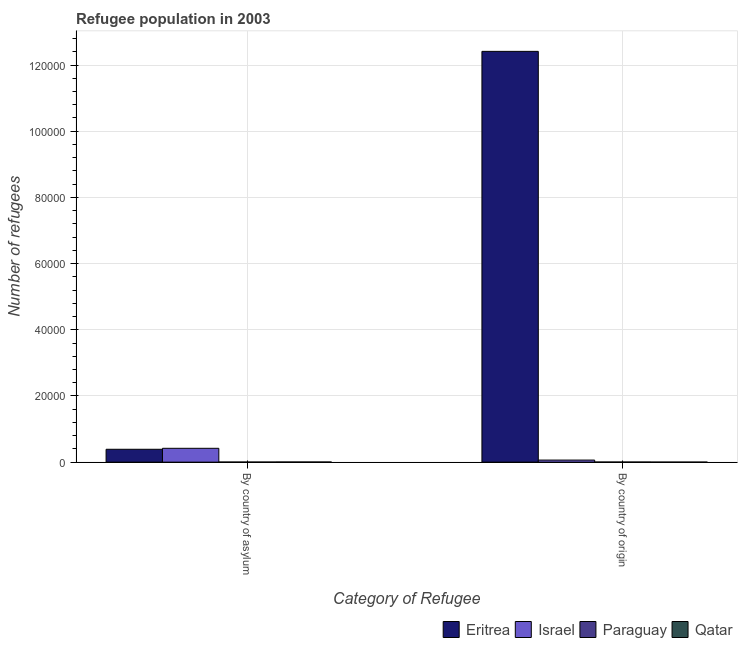How many different coloured bars are there?
Your answer should be very brief. 4. How many groups of bars are there?
Ensure brevity in your answer.  2. Are the number of bars on each tick of the X-axis equal?
Your response must be concise. Yes. How many bars are there on the 1st tick from the right?
Provide a succinct answer. 4. What is the label of the 2nd group of bars from the left?
Your response must be concise. By country of origin. What is the number of refugees by country of asylum in Paraguay?
Your answer should be very brief. 28. Across all countries, what is the maximum number of refugees by country of asylum?
Offer a terse response. 4179. Across all countries, what is the minimum number of refugees by country of origin?
Offer a very short reply. 13. In which country was the number of refugees by country of origin maximum?
Your response must be concise. Eritrea. In which country was the number of refugees by country of asylum minimum?
Offer a very short reply. Paraguay. What is the total number of refugees by country of asylum in the graph?
Provide a short and direct response. 8142. What is the difference between the number of refugees by country of origin in Paraguay and that in Eritrea?
Keep it short and to the point. -1.24e+05. What is the difference between the number of refugees by country of asylum in Paraguay and the number of refugees by country of origin in Qatar?
Keep it short and to the point. 15. What is the average number of refugees by country of asylum per country?
Make the answer very short. 2035.5. What is the difference between the number of refugees by country of origin and number of refugees by country of asylum in Eritrea?
Your response must be concise. 1.20e+05. In how many countries, is the number of refugees by country of origin greater than 52000 ?
Offer a terse response. 1. What is the ratio of the number of refugees by country of asylum in Eritrea to that in Israel?
Offer a terse response. 0.93. Is the number of refugees by country of asylum in Israel less than that in Eritrea?
Make the answer very short. No. In how many countries, is the number of refugees by country of asylum greater than the average number of refugees by country of asylum taken over all countries?
Make the answer very short. 2. What does the 4th bar from the left in By country of asylum represents?
Offer a very short reply. Qatar. What does the 4th bar from the right in By country of origin represents?
Provide a short and direct response. Eritrea. Are all the bars in the graph horizontal?
Ensure brevity in your answer.  No. How many countries are there in the graph?
Your response must be concise. 4. Are the values on the major ticks of Y-axis written in scientific E-notation?
Your response must be concise. No. Does the graph contain any zero values?
Offer a very short reply. No. Where does the legend appear in the graph?
Offer a terse response. Bottom right. How many legend labels are there?
Your response must be concise. 4. What is the title of the graph?
Keep it short and to the point. Refugee population in 2003. What is the label or title of the X-axis?
Your answer should be very brief. Category of Refugee. What is the label or title of the Y-axis?
Provide a succinct answer. Number of refugees. What is the Number of refugees in Eritrea in By country of asylum?
Your answer should be compact. 3889. What is the Number of refugees of Israel in By country of asylum?
Provide a succinct answer. 4179. What is the Number of refugees in Paraguay in By country of asylum?
Give a very brief answer. 28. What is the Number of refugees of Qatar in By country of asylum?
Ensure brevity in your answer.  46. What is the Number of refugees in Eritrea in By country of origin?
Ensure brevity in your answer.  1.24e+05. What is the Number of refugees in Israel in By country of origin?
Offer a terse response. 625. What is the Number of refugees in Paraguay in By country of origin?
Offer a very short reply. 32. Across all Category of Refugee, what is the maximum Number of refugees of Eritrea?
Offer a terse response. 1.24e+05. Across all Category of Refugee, what is the maximum Number of refugees in Israel?
Provide a succinct answer. 4179. Across all Category of Refugee, what is the maximum Number of refugees in Qatar?
Keep it short and to the point. 46. Across all Category of Refugee, what is the minimum Number of refugees in Eritrea?
Offer a very short reply. 3889. Across all Category of Refugee, what is the minimum Number of refugees in Israel?
Provide a short and direct response. 625. What is the total Number of refugees of Eritrea in the graph?
Offer a very short reply. 1.28e+05. What is the total Number of refugees of Israel in the graph?
Your answer should be very brief. 4804. What is the difference between the Number of refugees in Eritrea in By country of asylum and that in By country of origin?
Your response must be concise. -1.20e+05. What is the difference between the Number of refugees of Israel in By country of asylum and that in By country of origin?
Your answer should be very brief. 3554. What is the difference between the Number of refugees of Paraguay in By country of asylum and that in By country of origin?
Make the answer very short. -4. What is the difference between the Number of refugees of Eritrea in By country of asylum and the Number of refugees of Israel in By country of origin?
Provide a succinct answer. 3264. What is the difference between the Number of refugees of Eritrea in By country of asylum and the Number of refugees of Paraguay in By country of origin?
Offer a terse response. 3857. What is the difference between the Number of refugees in Eritrea in By country of asylum and the Number of refugees in Qatar in By country of origin?
Your answer should be very brief. 3876. What is the difference between the Number of refugees in Israel in By country of asylum and the Number of refugees in Paraguay in By country of origin?
Make the answer very short. 4147. What is the difference between the Number of refugees in Israel in By country of asylum and the Number of refugees in Qatar in By country of origin?
Ensure brevity in your answer.  4166. What is the average Number of refugees of Eritrea per Category of Refugee?
Offer a terse response. 6.40e+04. What is the average Number of refugees in Israel per Category of Refugee?
Ensure brevity in your answer.  2402. What is the average Number of refugees in Paraguay per Category of Refugee?
Your response must be concise. 30. What is the average Number of refugees of Qatar per Category of Refugee?
Make the answer very short. 29.5. What is the difference between the Number of refugees in Eritrea and Number of refugees in Israel in By country of asylum?
Your response must be concise. -290. What is the difference between the Number of refugees in Eritrea and Number of refugees in Paraguay in By country of asylum?
Ensure brevity in your answer.  3861. What is the difference between the Number of refugees of Eritrea and Number of refugees of Qatar in By country of asylum?
Make the answer very short. 3843. What is the difference between the Number of refugees of Israel and Number of refugees of Paraguay in By country of asylum?
Keep it short and to the point. 4151. What is the difference between the Number of refugees in Israel and Number of refugees in Qatar in By country of asylum?
Your response must be concise. 4133. What is the difference between the Number of refugees of Paraguay and Number of refugees of Qatar in By country of asylum?
Offer a very short reply. -18. What is the difference between the Number of refugees of Eritrea and Number of refugees of Israel in By country of origin?
Offer a terse response. 1.23e+05. What is the difference between the Number of refugees in Eritrea and Number of refugees in Paraguay in By country of origin?
Ensure brevity in your answer.  1.24e+05. What is the difference between the Number of refugees of Eritrea and Number of refugees of Qatar in By country of origin?
Keep it short and to the point. 1.24e+05. What is the difference between the Number of refugees in Israel and Number of refugees in Paraguay in By country of origin?
Offer a very short reply. 593. What is the difference between the Number of refugees of Israel and Number of refugees of Qatar in By country of origin?
Ensure brevity in your answer.  612. What is the difference between the Number of refugees in Paraguay and Number of refugees in Qatar in By country of origin?
Ensure brevity in your answer.  19. What is the ratio of the Number of refugees of Eritrea in By country of asylum to that in By country of origin?
Offer a terse response. 0.03. What is the ratio of the Number of refugees in Israel in By country of asylum to that in By country of origin?
Keep it short and to the point. 6.69. What is the ratio of the Number of refugees in Qatar in By country of asylum to that in By country of origin?
Your response must be concise. 3.54. What is the difference between the highest and the second highest Number of refugees of Eritrea?
Your response must be concise. 1.20e+05. What is the difference between the highest and the second highest Number of refugees of Israel?
Offer a very short reply. 3554. What is the difference between the highest and the second highest Number of refugees in Paraguay?
Your response must be concise. 4. What is the difference between the highest and the second highest Number of refugees in Qatar?
Ensure brevity in your answer.  33. What is the difference between the highest and the lowest Number of refugees of Eritrea?
Provide a short and direct response. 1.20e+05. What is the difference between the highest and the lowest Number of refugees in Israel?
Provide a succinct answer. 3554. What is the difference between the highest and the lowest Number of refugees in Paraguay?
Keep it short and to the point. 4. What is the difference between the highest and the lowest Number of refugees of Qatar?
Your response must be concise. 33. 